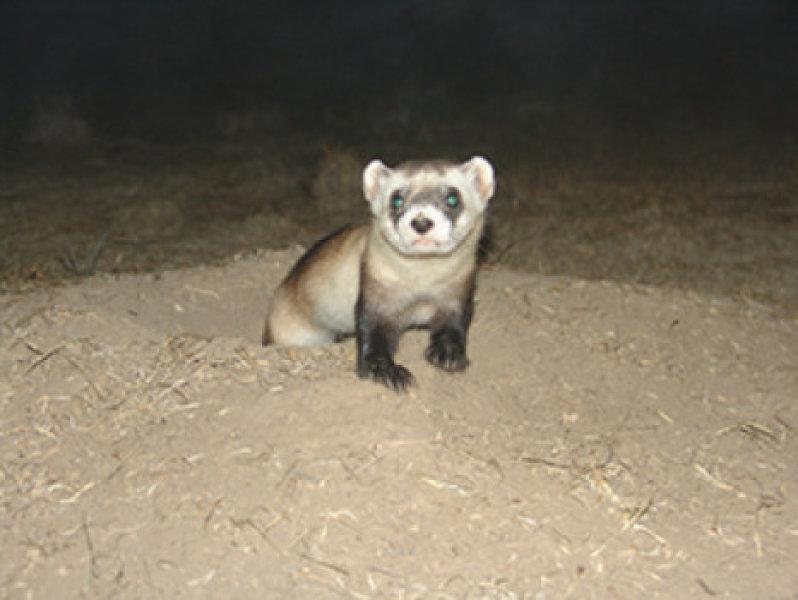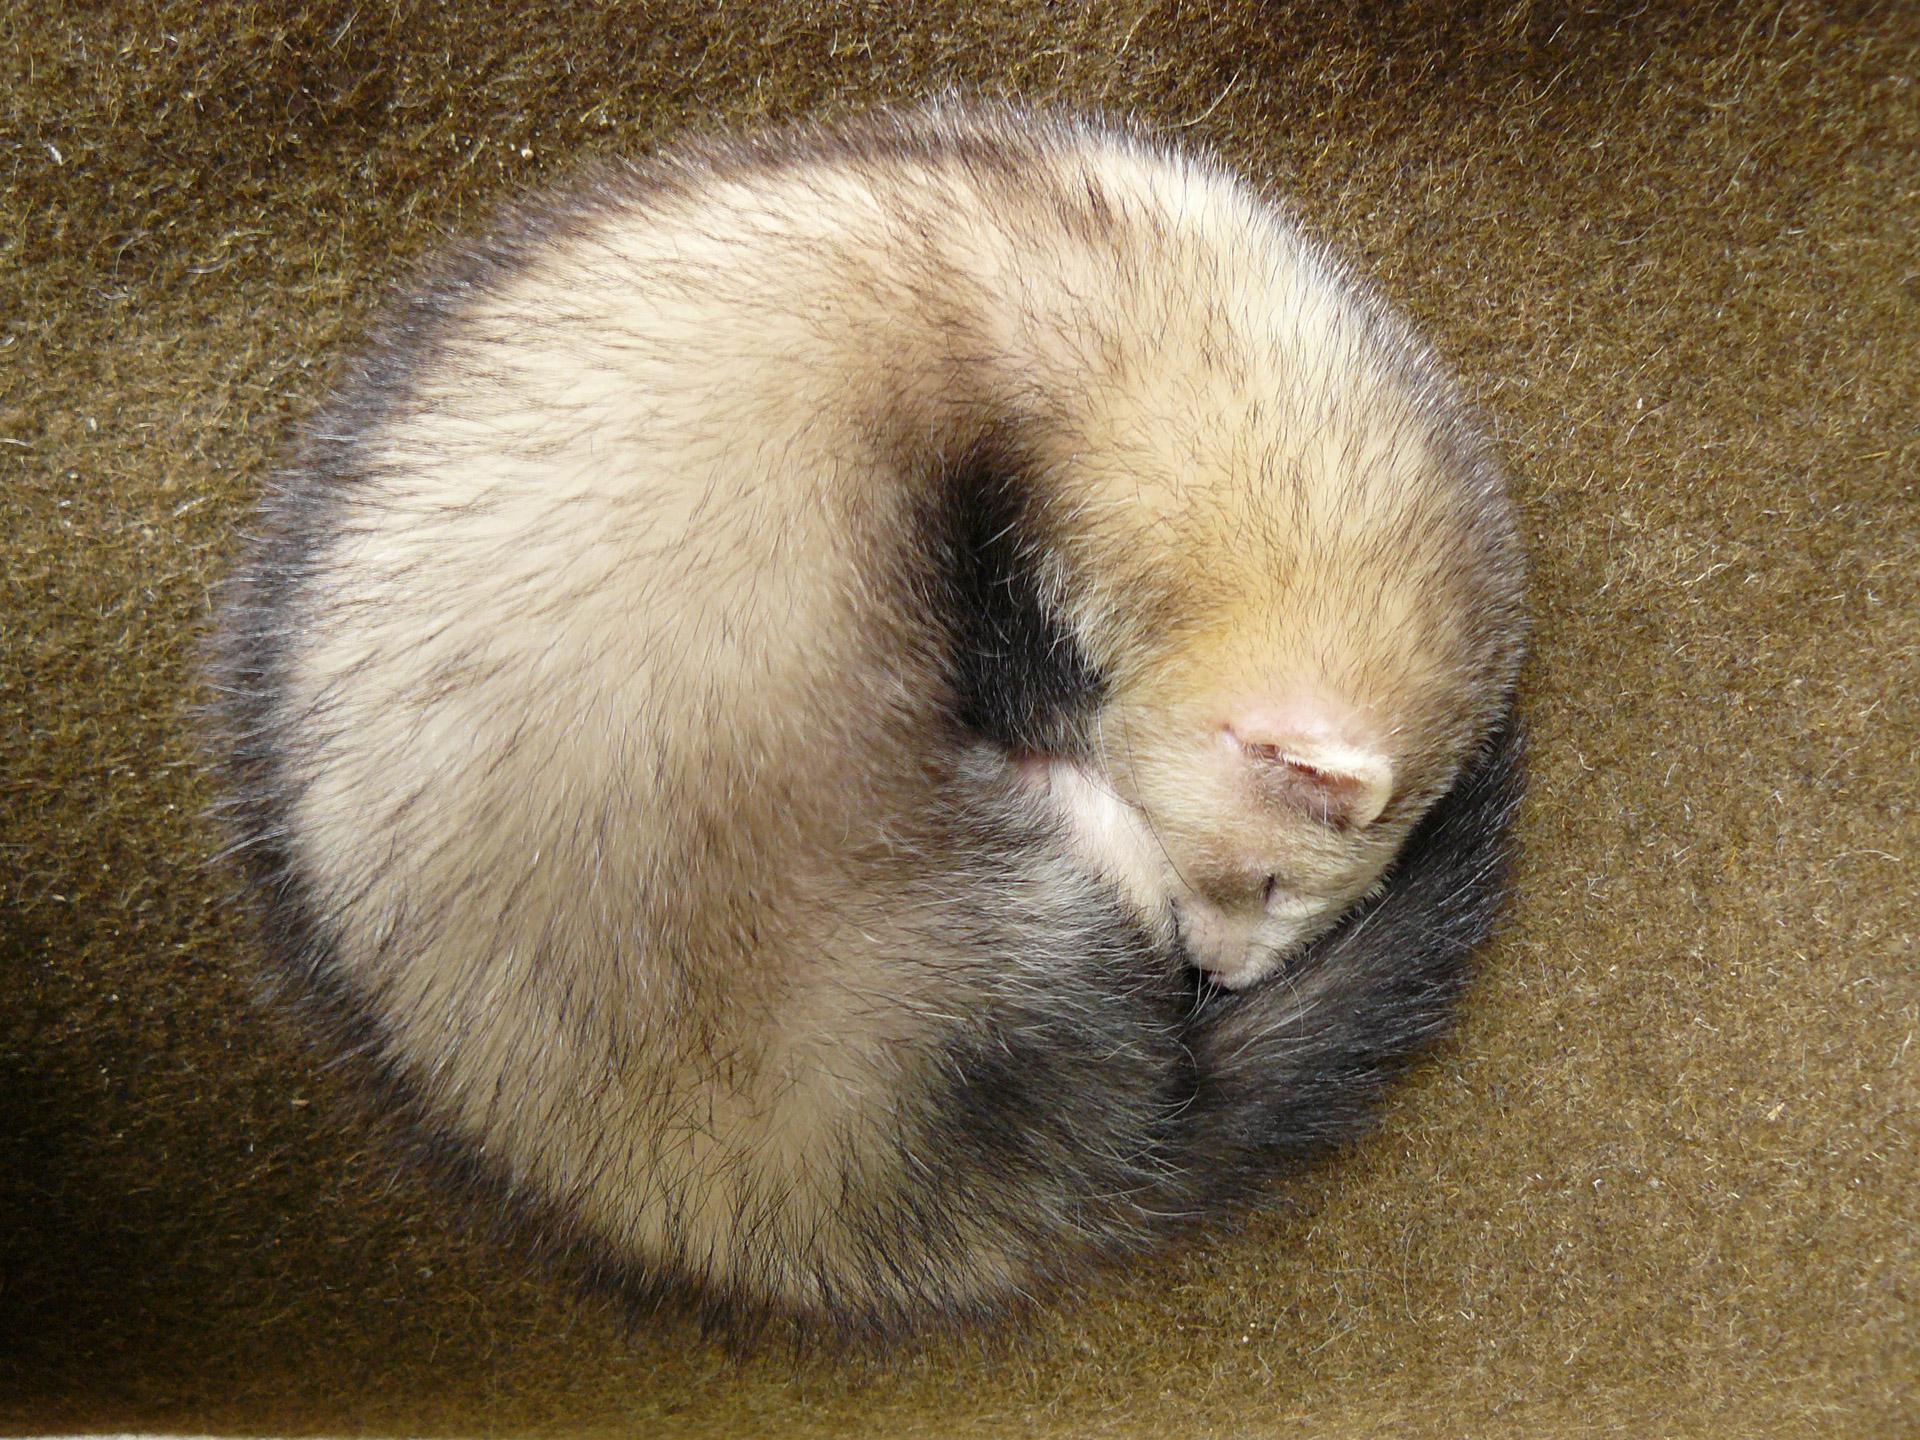The first image is the image on the left, the second image is the image on the right. Evaluate the accuracy of this statement regarding the images: "One image shows a single ferret with its head raised and gazing leftward.". Is it true? Answer yes or no. No. The first image is the image on the left, the second image is the image on the right. Analyze the images presented: Is the assertion "The right image contains exactly one ferret curled up on the floor." valid? Answer yes or no. Yes. 